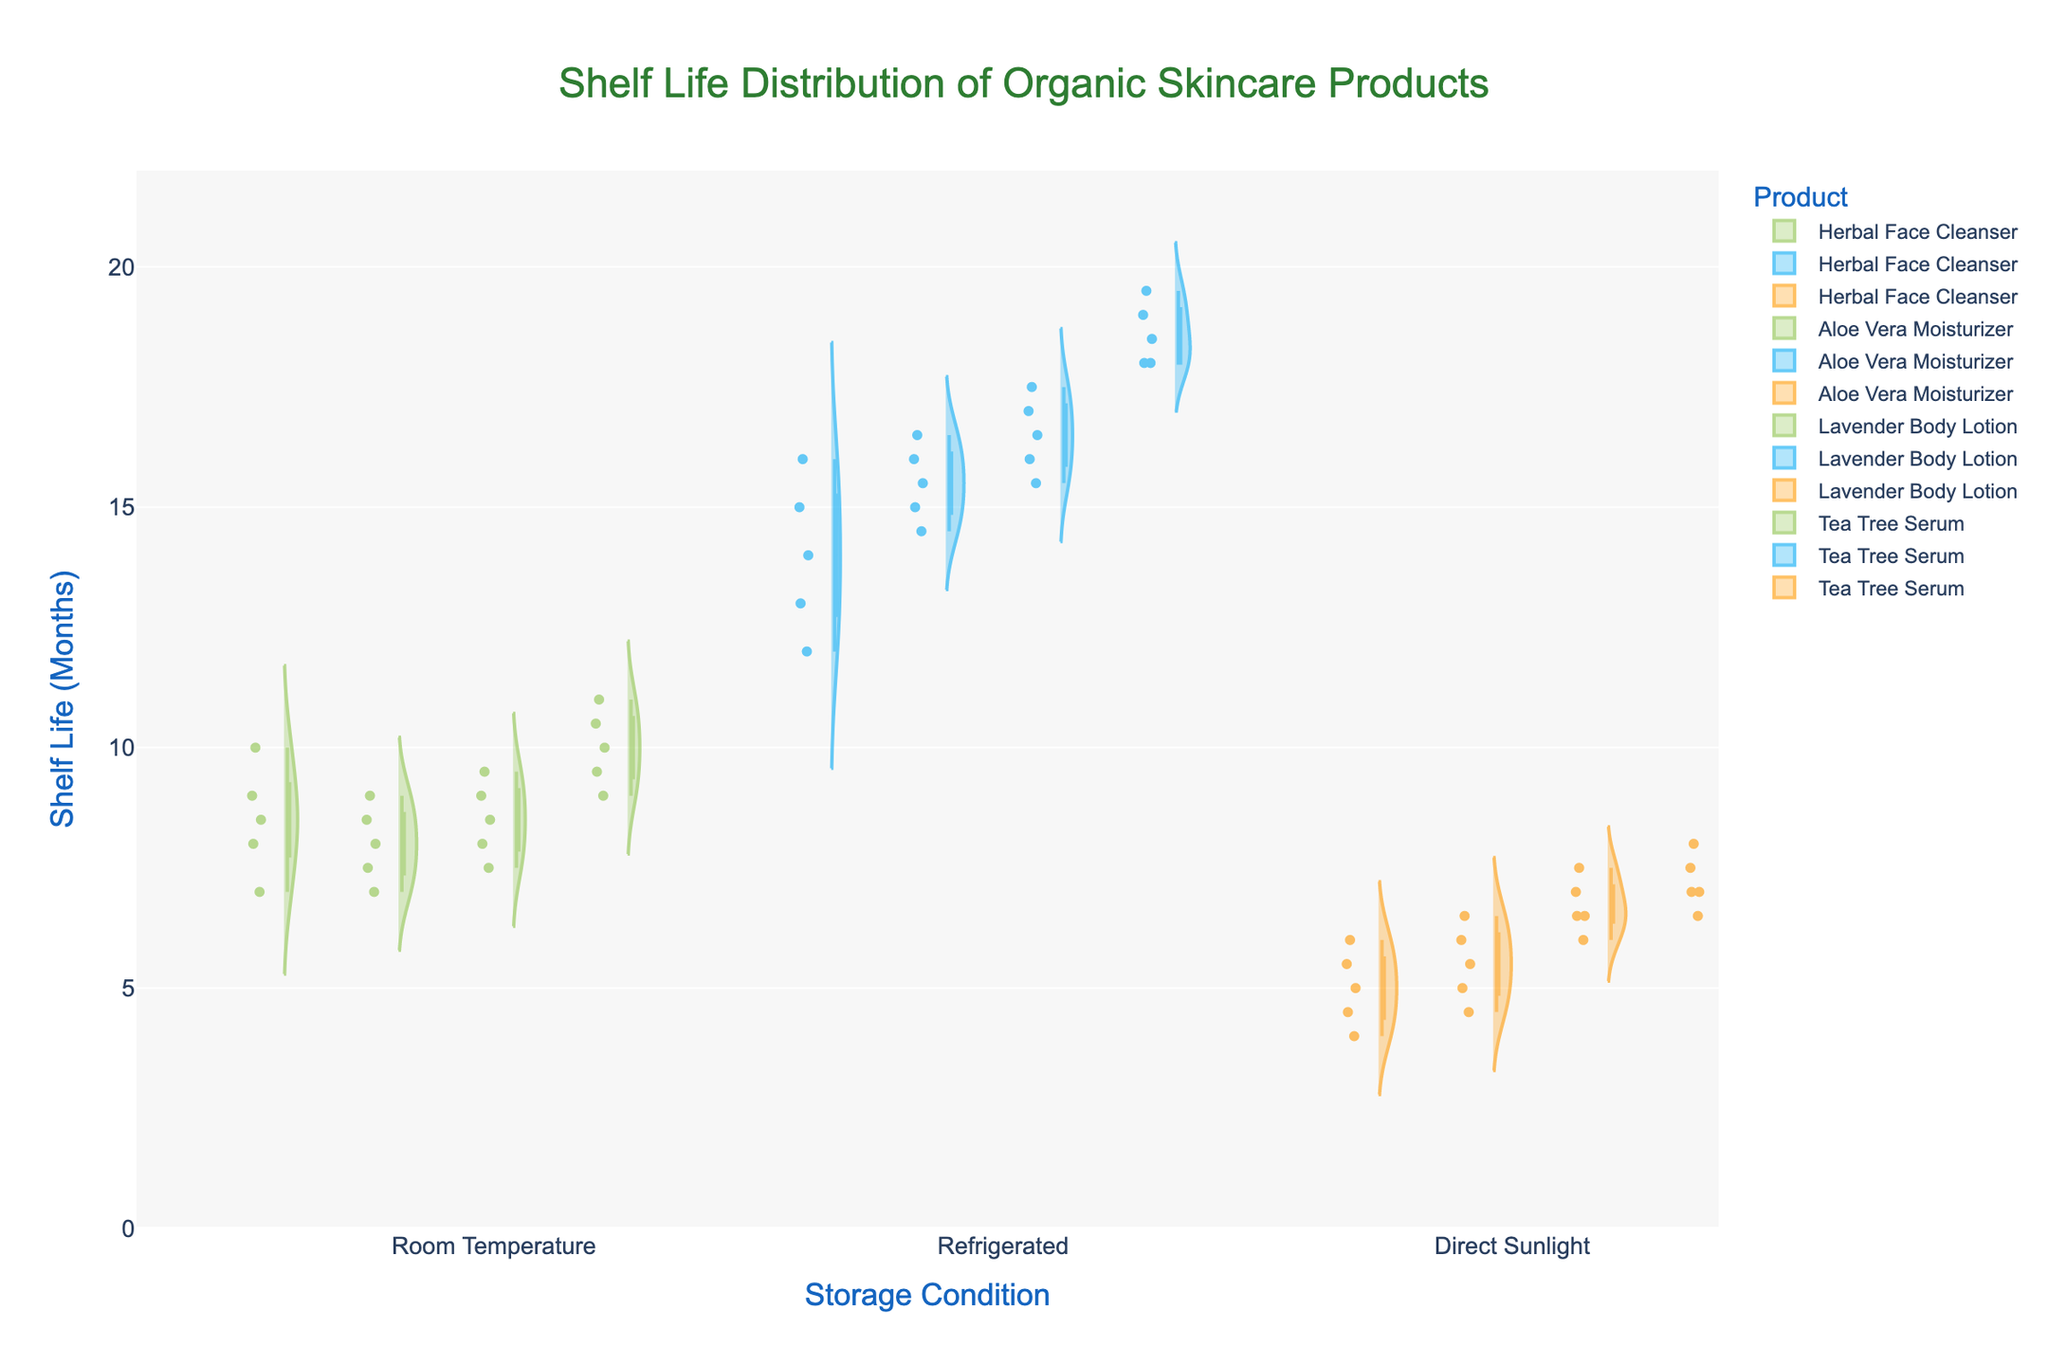How many products are displayed in the plot? Count the unique products listed in the legend or the plot itself. Each product will have its own violin plot.
Answer: 4 What are the storage conditions analyzed in the plot? Look at the x-axis' tick labels which represent different storage conditions.
Answer: Room Temperature, Refrigerated, Direct Sunlight Which product has the highest median shelf life in refrigerated storage? Identify the product with the highest box plot median line within the 'Refrigerated' group.
Answer: Tea Tree Serum Among the products stored at room temperature, which has the widest range of shelf life? Identify the product with the largest vertical span between the minimum and maximum values in the box plot for the 'Room Temperature' group.
Answer: Tea Tree Serum What's the average shelf life for Lavender Body Lotion in direct sunlight, based on the data points shown in the plot? Add up the shelf life values for Lavender Body Lotion stored in direct sunlight and divide by the number of data points. (7+6.5+6+7.5+6.5)/5 = 33.5/5
Answer: 6.7 Which storage condition generally results in the shortest shelf life for all products? Compare the highest points (upper whiskers) of the box plots across all products in different storage conditions and find the condition with the lowest maximum values.
Answer: Direct Sunlight In the violin plots for refrigerated storage, which product displays the most varied distribution of shelf life? Look for the product with the widest violin spread in the 'Refrigerated' condition, indicating the most variability.
Answer: Tea Tree Serum Does Aloe Vera Moisturizer have a greater median shelf life in direct sunlight or room temperature? Compare the median lines of the box plots for Aloe Vera Moisturizer in these two conditions.
Answer: Room Temperature Which storage condition shows clusters of data points around the mean for Herbal Face Cleanser? Check the density and concentration of data points around the mean line inside the violin plot for Herbal Face Cleanser across all storage conditions.
Answer: Refrigerated 